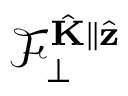Convert formula to latex. <formula><loc_0><loc_0><loc_500><loc_500>\mathcal { F } _ { \perp } ^ { \hat { K } \| \hat { z } }</formula> 